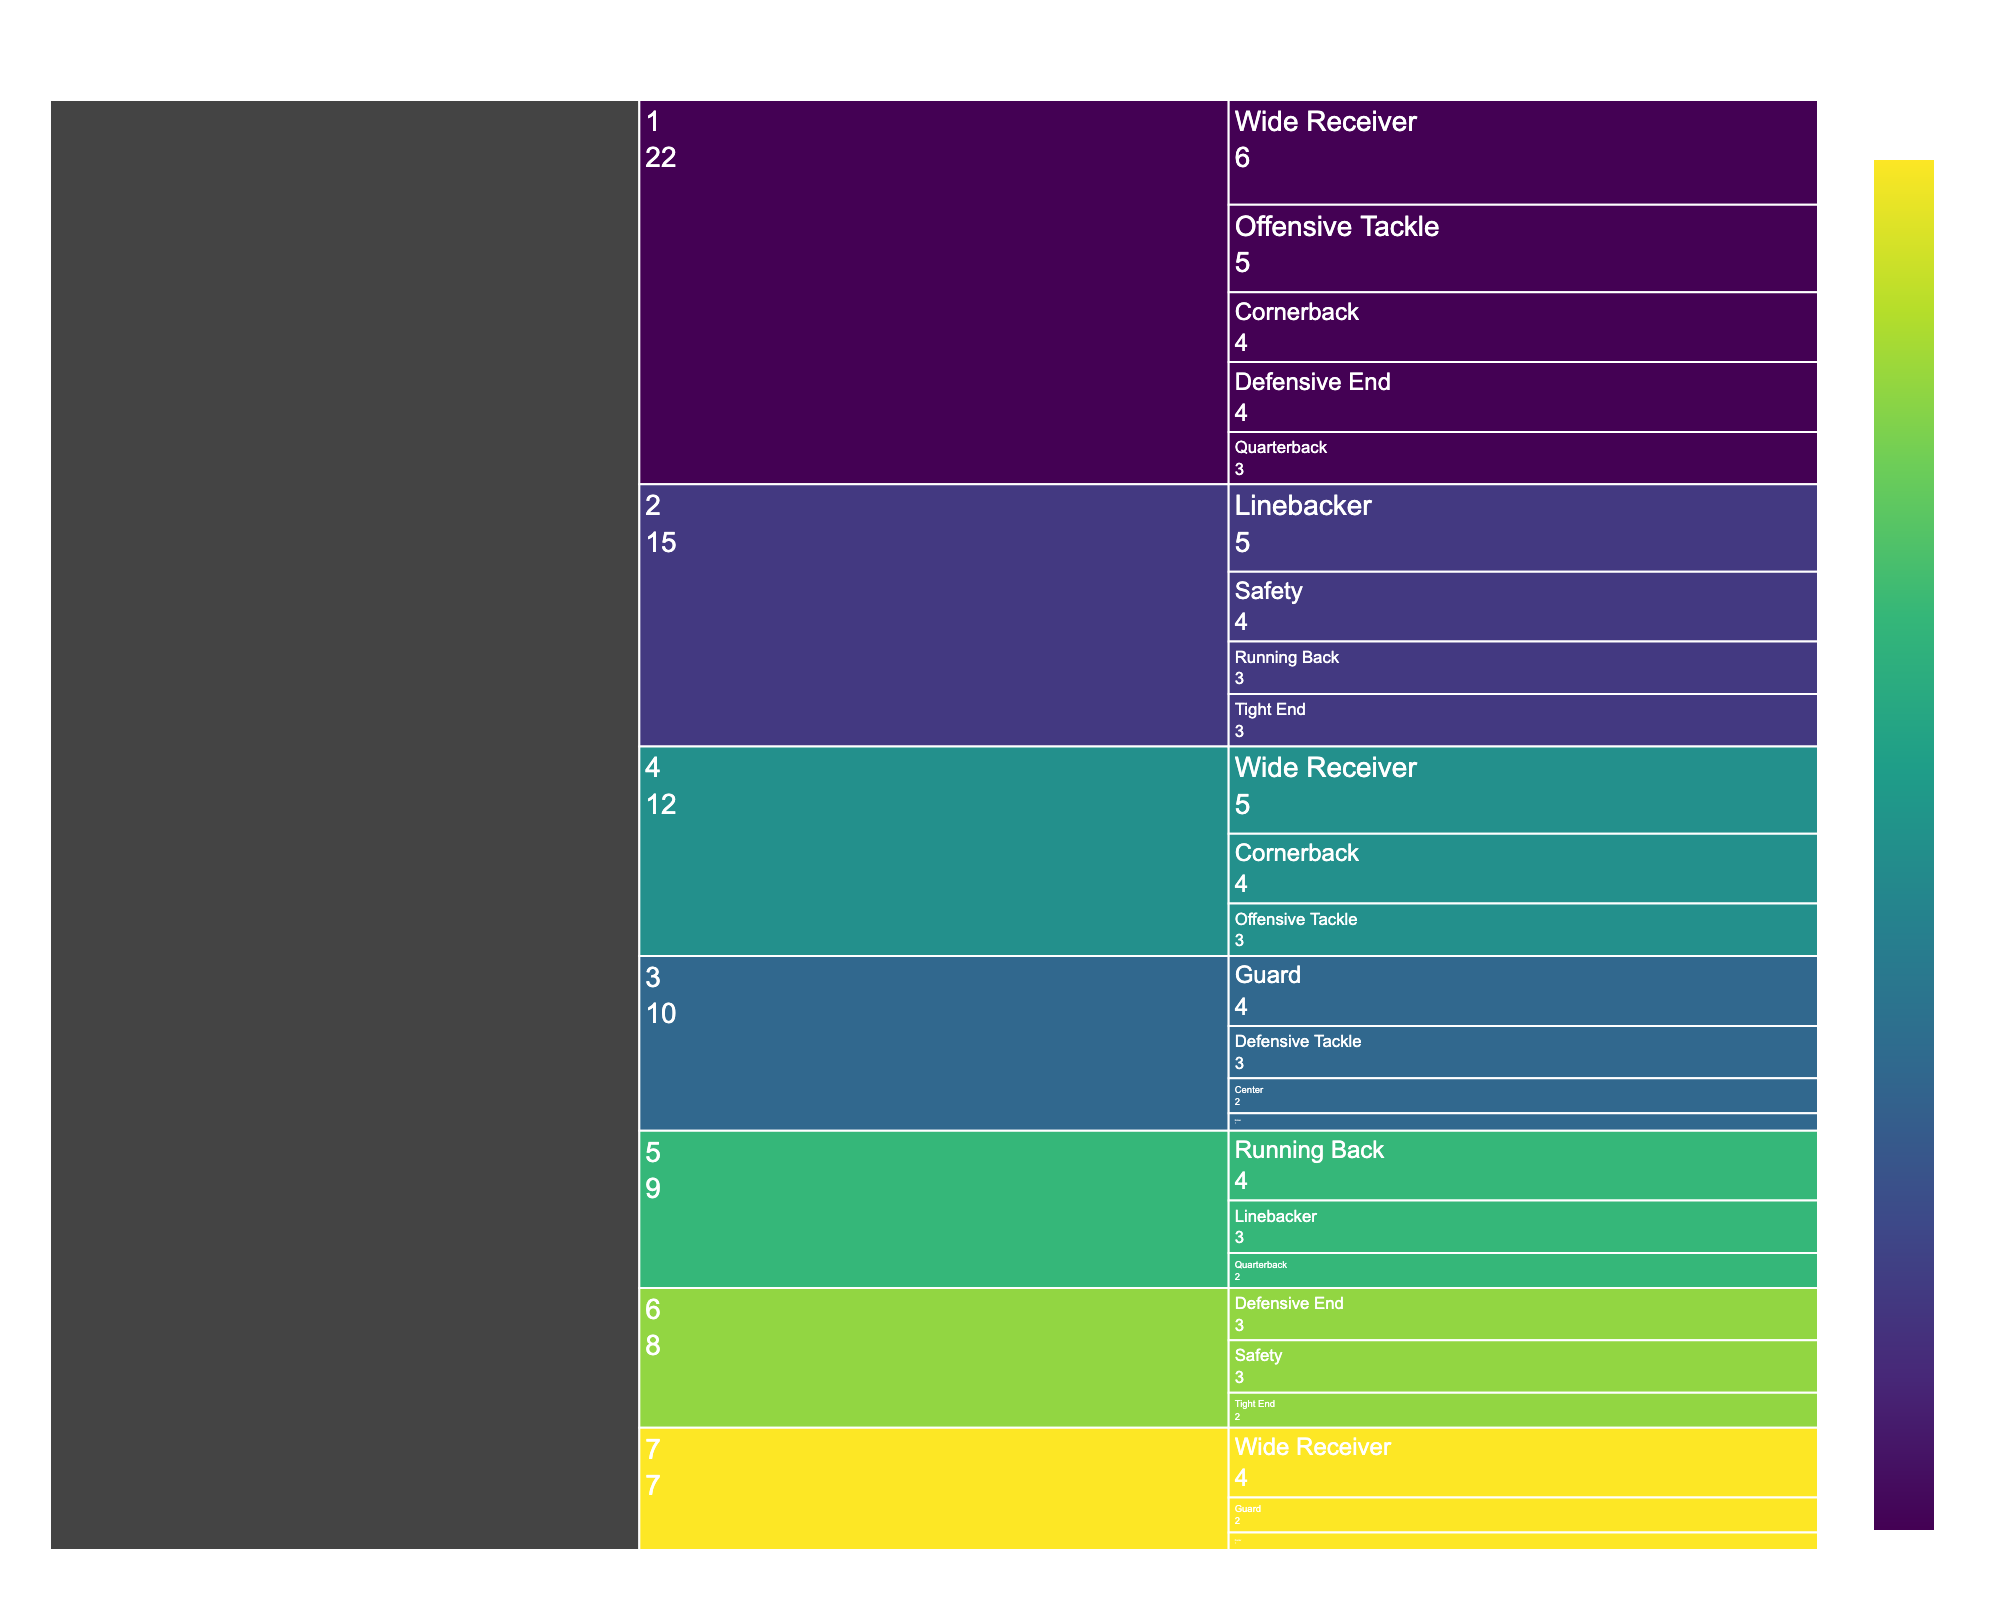what is the title of the chart? The title of the chart is located at the top and provides an overview of the data being represented.
Answer: NFL Draft Selection Distribution by Round and Position Which round has the highest total number of selections? To find the round with the highest total selections, sum the count of players in each round and compare. Round 1: 3 + 5 + 6 + 4 + 4 = 22 players. Round 2: 3 + 5 + 4 + 3 = 15 players. Round 3: 4 + 2 + 3 + 1 = 10 players. Round 4: 5 + 4 + 3 = 12 players. Round 5: 2 + 4 + 3 = 9 players. Round 6: 3 + 2 + 3 = 8 players. Round 7: 2 + 1 + 4 = 7 players. Thus, Round 1 has the highest total number of selections.
Answer: Round 1 What positions were selected in Round 4 and how many players were selected for each position? Examine the icicle chart to find the data for Round 4. The positions are Wide Receiver with 5 players, Cornerback with 4 players, and Offensive Tackle with 3 players.
Answer: Wide Receiver: 5, Cornerback: 4, Offensive Tackle: 3 Which position has the lowest number of selections across all rounds and what is that number? Identify the position with the smallest count in the icicle chart. Punter has the lowest number with only 1 selection in Round 7, and Kicker has only 1 selection in Round 3.
Answer: Punter and Kicker: 1 How many more Wide Receivers were selected in Round 1 compared to Round 7? Calculate the difference in selections of Wide Receivers between Round 1 and Round 7. Round 1 has 6 Wide Receivers and Round 7 has 4 Wide Receivers. 6 - 4 = 2 more Wide Receivers were selected in Round 1.
Answer: 2 more Which round has more Quarterbacks selected and by how many? Count the number of Quarterbacks selected in each round. Round 1 has 3 Quarterbacks and Round 5 has 2 Quarterbacks. 3 - 2 = 1 more Quarterback was selected in Round 1 compared to Round 5.
Answer: Round 1 has 1 more quarterback Which positions have an equal number of selections in Round 1? Compare the count of players for each position in Round 1. Both Defensive End and Cornerback have 4 players each.
Answer: Defensive End and Cornerback How many total selections were made for the Safety position across all rounds? Sum the count of Safety players from all rounds. Round 2 has 4 Safeties and Round 6 has 3 Safeties. 4 + 3 = 7 Safeties were selected.
Answer: 7 